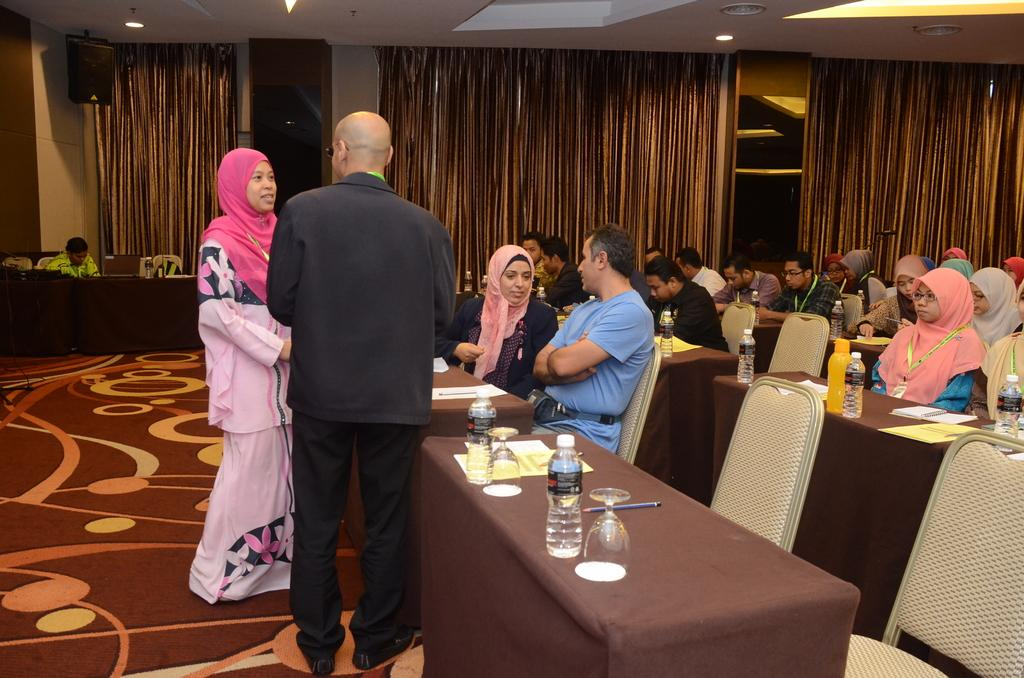What are the people in the image doing? There are people sitting on chairs in the image, and they are having a conversation. How many people can be seen in the image? There are at least two people in the image. What is the purpose of the glass window in the image? The glass window is not mentioned to have a specific purpose, but it is visible in the image. What is the relationship between the glass window and the curtain? The glass window is bounded by a curtain in the image. What type of magic is being performed by the people in the image? There is no indication of magic or any magical activity in the image. The people are simply having a conversation while sitting on chairs. 